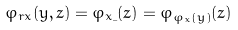Convert formula to latex. <formula><loc_0><loc_0><loc_500><loc_500>\varphi _ { r x } ( y , z ) = \varphi _ { x \_ } ( z ) = \varphi _ { \varphi _ { x } ( y ) } ( z )</formula> 